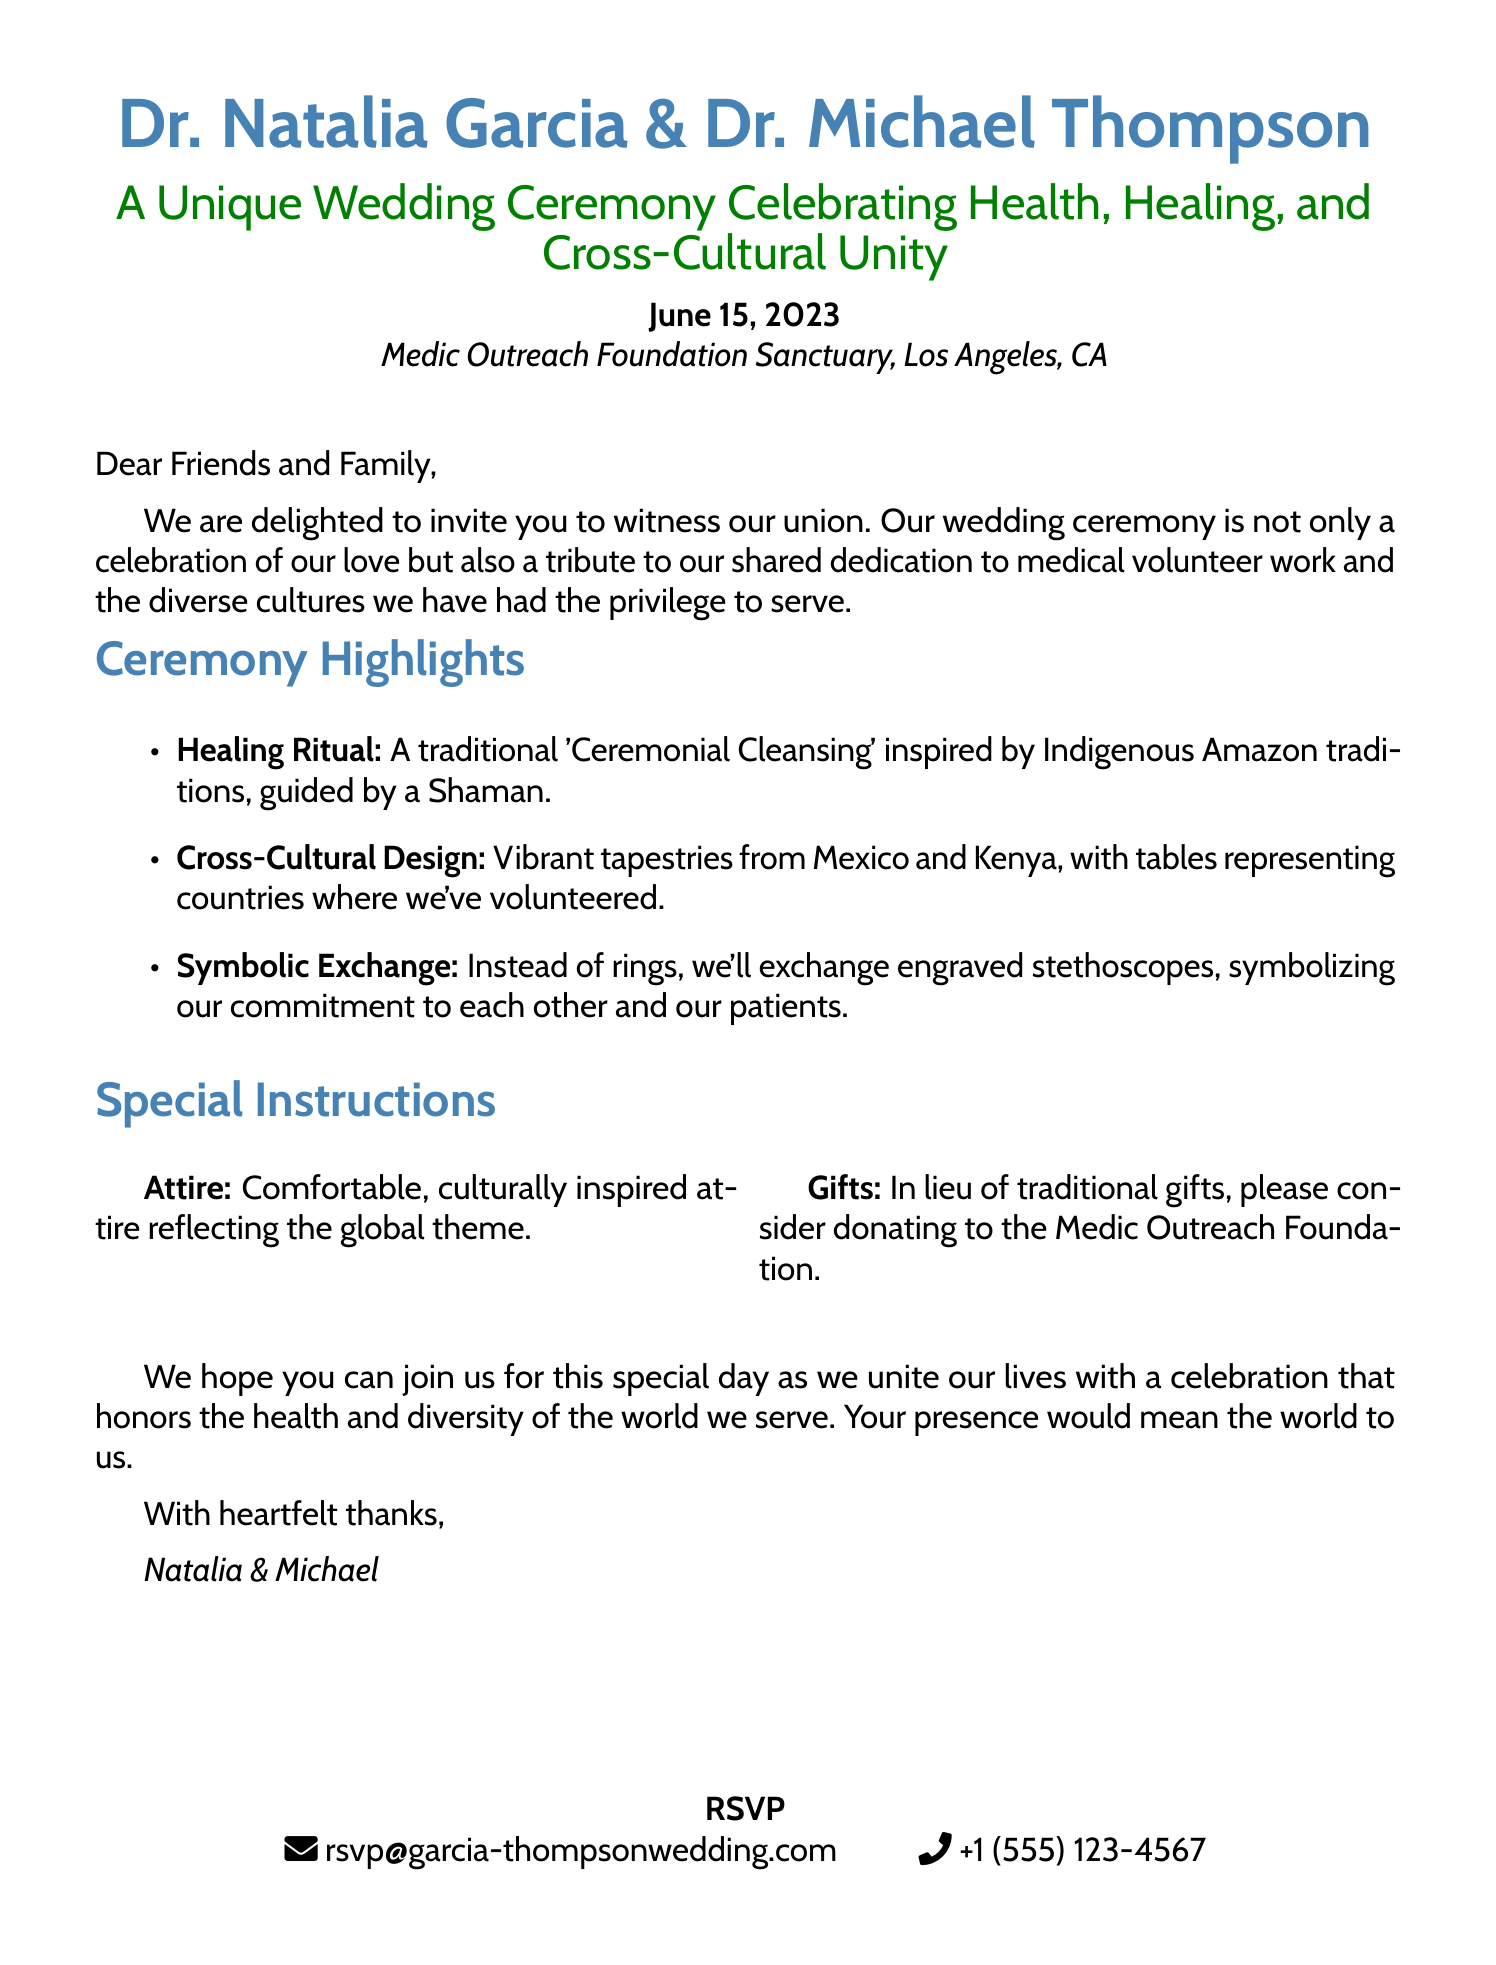What are the names of the couple? The names of the couple are stated at the beginning of the invitation.
Answer: Dr. Natalia Garcia & Dr. Michael Thompson What is the date of the wedding ceremony? The date of the wedding ceremony is specified in the document.
Answer: June 15, 2023 Where is the wedding ceremony taking place? The location of the ceremony is listed in the invitation.
Answer: Medic Outreach Foundation Sanctuary, Los Angeles, CA What is a highlighted feature of the ceremony? The document lists several highlights of the ceremony.
Answer: Healing Ritual What alternative gift suggestion is mentioned? The invitation suggests an alternative to traditional wedding gifts.
Answer: Donating to the Medic Outreach Foundation What type of attire is requested? The invitation includes a note about the type of attire guests should wear.
Answer: Comfortable, culturally inspired attire What symbolizes the couple's commitment to each other? The document mentions a unique item to be exchanged during the ceremony.
Answer: Engraved stethoscopes What type of unity does the wedding celebrate? The invitation emphasizes the broader theme of the ceremony.
Answer: Cross-Cultural Unity 